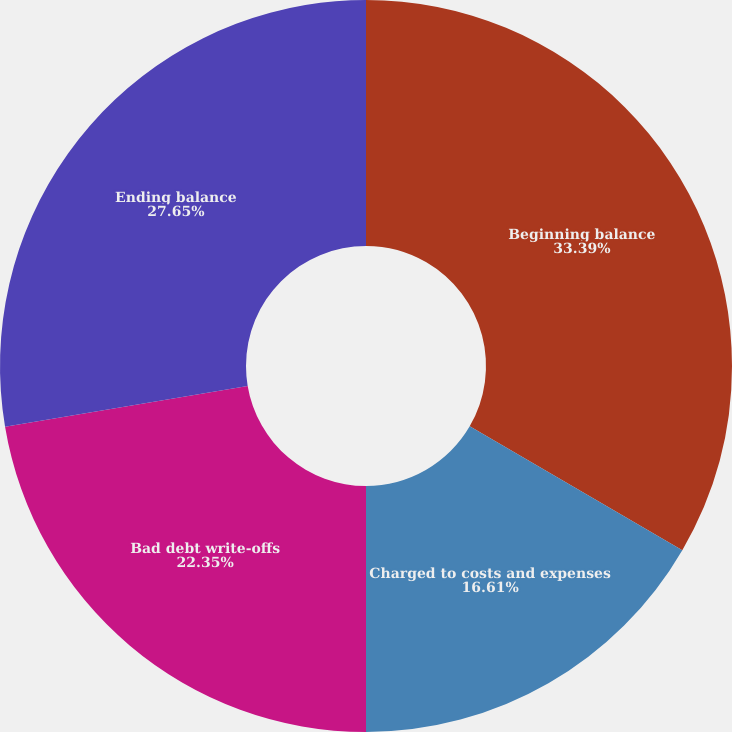Convert chart. <chart><loc_0><loc_0><loc_500><loc_500><pie_chart><fcel>Beginning balance<fcel>Charged to costs and expenses<fcel>Bad debt write-offs<fcel>Ending balance<nl><fcel>33.39%<fcel>16.61%<fcel>22.35%<fcel>27.65%<nl></chart> 